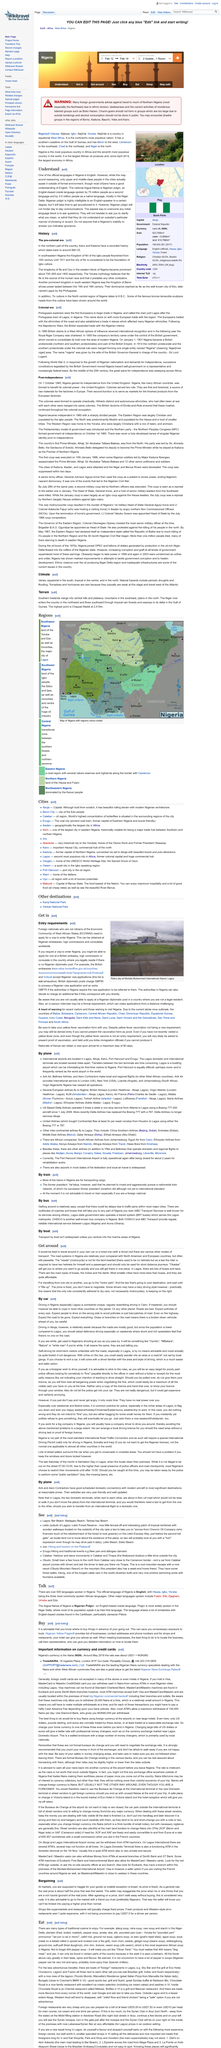Specify some key components in this picture. As of 2021, an estimated 75 million people worldwide speak Nigerian Pidgin as a second language, while 3-5 million people primarily use it as their native tongue. The Niger river enters the country in the northwest. Yes, according to the article "Talk," there are over 500 languages spoken in Nigeria. The airport depicted in the picture is located in Lagos. Yes, Nigerian peppers are very hot and spicy. 